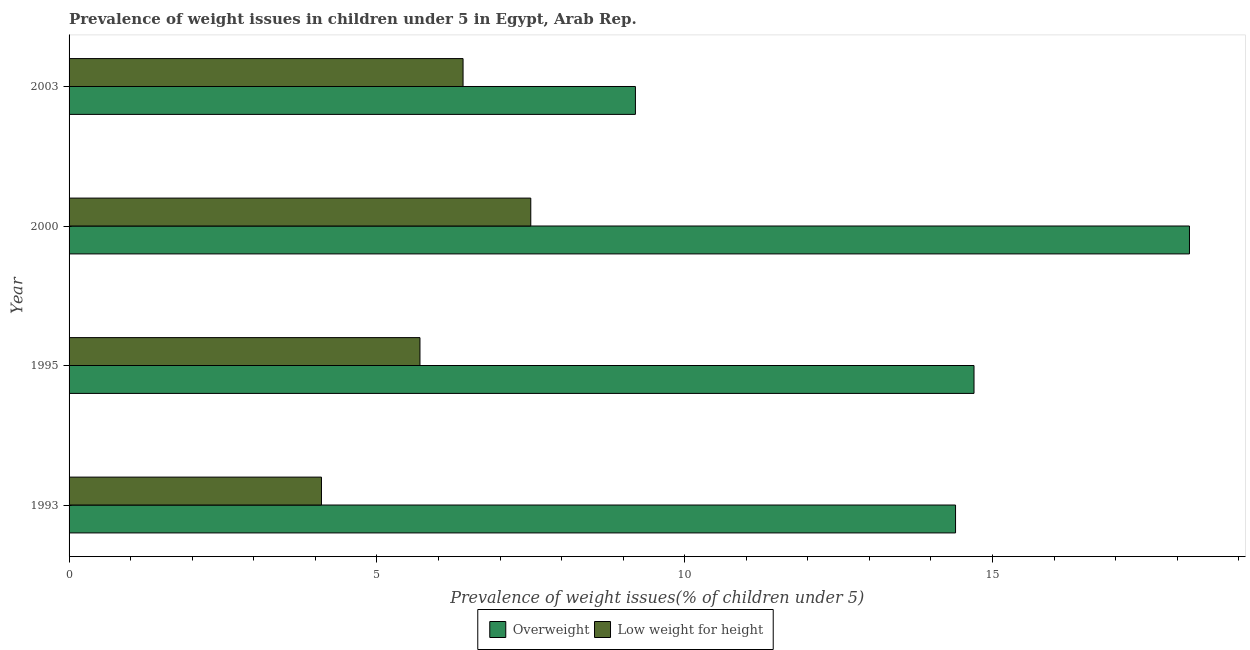How many different coloured bars are there?
Provide a short and direct response. 2. Are the number of bars per tick equal to the number of legend labels?
Ensure brevity in your answer.  Yes. How many bars are there on the 3rd tick from the top?
Your answer should be compact. 2. What is the label of the 4th group of bars from the top?
Give a very brief answer. 1993. What is the percentage of underweight children in 2000?
Your answer should be compact. 7.5. Across all years, what is the maximum percentage of underweight children?
Give a very brief answer. 7.5. Across all years, what is the minimum percentage of overweight children?
Give a very brief answer. 9.2. In which year was the percentage of underweight children maximum?
Ensure brevity in your answer.  2000. In which year was the percentage of underweight children minimum?
Your response must be concise. 1993. What is the total percentage of overweight children in the graph?
Provide a succinct answer. 56.5. What is the difference between the percentage of overweight children in 1993 and that in 2000?
Keep it short and to the point. -3.8. What is the difference between the percentage of overweight children in 1995 and the percentage of underweight children in 2003?
Ensure brevity in your answer.  8.3. What is the average percentage of underweight children per year?
Offer a very short reply. 5.92. In how many years, is the percentage of overweight children greater than 12 %?
Give a very brief answer. 3. Is the percentage of overweight children in 2000 less than that in 2003?
Offer a very short reply. No. Is the difference between the percentage of overweight children in 1995 and 2003 greater than the difference between the percentage of underweight children in 1995 and 2003?
Offer a terse response. Yes. What does the 1st bar from the top in 1995 represents?
Provide a succinct answer. Low weight for height. What does the 1st bar from the bottom in 1993 represents?
Provide a succinct answer. Overweight. How many bars are there?
Your answer should be very brief. 8. Are all the bars in the graph horizontal?
Keep it short and to the point. Yes. How many years are there in the graph?
Offer a very short reply. 4. What is the difference between two consecutive major ticks on the X-axis?
Ensure brevity in your answer.  5. Does the graph contain grids?
Keep it short and to the point. No. How many legend labels are there?
Your response must be concise. 2. What is the title of the graph?
Your response must be concise. Prevalence of weight issues in children under 5 in Egypt, Arab Rep. What is the label or title of the X-axis?
Provide a succinct answer. Prevalence of weight issues(% of children under 5). What is the label or title of the Y-axis?
Your answer should be compact. Year. What is the Prevalence of weight issues(% of children under 5) in Overweight in 1993?
Your answer should be very brief. 14.4. What is the Prevalence of weight issues(% of children under 5) in Low weight for height in 1993?
Keep it short and to the point. 4.1. What is the Prevalence of weight issues(% of children under 5) in Overweight in 1995?
Make the answer very short. 14.7. What is the Prevalence of weight issues(% of children under 5) in Low weight for height in 1995?
Your answer should be compact. 5.7. What is the Prevalence of weight issues(% of children under 5) of Overweight in 2000?
Your response must be concise. 18.2. What is the Prevalence of weight issues(% of children under 5) of Low weight for height in 2000?
Give a very brief answer. 7.5. What is the Prevalence of weight issues(% of children under 5) of Overweight in 2003?
Make the answer very short. 9.2. What is the Prevalence of weight issues(% of children under 5) of Low weight for height in 2003?
Your answer should be very brief. 6.4. Across all years, what is the maximum Prevalence of weight issues(% of children under 5) of Overweight?
Offer a terse response. 18.2. Across all years, what is the maximum Prevalence of weight issues(% of children under 5) in Low weight for height?
Your answer should be very brief. 7.5. Across all years, what is the minimum Prevalence of weight issues(% of children under 5) of Overweight?
Make the answer very short. 9.2. Across all years, what is the minimum Prevalence of weight issues(% of children under 5) of Low weight for height?
Keep it short and to the point. 4.1. What is the total Prevalence of weight issues(% of children under 5) in Overweight in the graph?
Provide a short and direct response. 56.5. What is the total Prevalence of weight issues(% of children under 5) in Low weight for height in the graph?
Ensure brevity in your answer.  23.7. What is the difference between the Prevalence of weight issues(% of children under 5) in Overweight in 1993 and that in 1995?
Give a very brief answer. -0.3. What is the difference between the Prevalence of weight issues(% of children under 5) of Low weight for height in 1993 and that in 1995?
Your response must be concise. -1.6. What is the difference between the Prevalence of weight issues(% of children under 5) in Overweight in 1993 and that in 2003?
Provide a short and direct response. 5.2. What is the difference between the Prevalence of weight issues(% of children under 5) in Low weight for height in 1993 and that in 2003?
Give a very brief answer. -2.3. What is the difference between the Prevalence of weight issues(% of children under 5) in Overweight in 1995 and that in 2003?
Your answer should be compact. 5.5. What is the difference between the Prevalence of weight issues(% of children under 5) in Low weight for height in 1995 and that in 2003?
Your answer should be compact. -0.7. What is the difference between the Prevalence of weight issues(% of children under 5) in Overweight in 2000 and that in 2003?
Keep it short and to the point. 9. What is the difference between the Prevalence of weight issues(% of children under 5) in Overweight in 1993 and the Prevalence of weight issues(% of children under 5) in Low weight for height in 1995?
Your answer should be compact. 8.7. What is the difference between the Prevalence of weight issues(% of children under 5) in Overweight in 1993 and the Prevalence of weight issues(% of children under 5) in Low weight for height in 2003?
Make the answer very short. 8. What is the difference between the Prevalence of weight issues(% of children under 5) in Overweight in 1995 and the Prevalence of weight issues(% of children under 5) in Low weight for height in 2000?
Offer a very short reply. 7.2. What is the difference between the Prevalence of weight issues(% of children under 5) of Overweight in 1995 and the Prevalence of weight issues(% of children under 5) of Low weight for height in 2003?
Offer a very short reply. 8.3. What is the difference between the Prevalence of weight issues(% of children under 5) in Overweight in 2000 and the Prevalence of weight issues(% of children under 5) in Low weight for height in 2003?
Provide a short and direct response. 11.8. What is the average Prevalence of weight issues(% of children under 5) in Overweight per year?
Your response must be concise. 14.12. What is the average Prevalence of weight issues(% of children under 5) in Low weight for height per year?
Offer a terse response. 5.92. In the year 1995, what is the difference between the Prevalence of weight issues(% of children under 5) in Overweight and Prevalence of weight issues(% of children under 5) in Low weight for height?
Your answer should be very brief. 9. In the year 2000, what is the difference between the Prevalence of weight issues(% of children under 5) of Overweight and Prevalence of weight issues(% of children under 5) of Low weight for height?
Provide a succinct answer. 10.7. In the year 2003, what is the difference between the Prevalence of weight issues(% of children under 5) in Overweight and Prevalence of weight issues(% of children under 5) in Low weight for height?
Give a very brief answer. 2.8. What is the ratio of the Prevalence of weight issues(% of children under 5) in Overweight in 1993 to that in 1995?
Your response must be concise. 0.98. What is the ratio of the Prevalence of weight issues(% of children under 5) in Low weight for height in 1993 to that in 1995?
Ensure brevity in your answer.  0.72. What is the ratio of the Prevalence of weight issues(% of children under 5) of Overweight in 1993 to that in 2000?
Offer a very short reply. 0.79. What is the ratio of the Prevalence of weight issues(% of children under 5) in Low weight for height in 1993 to that in 2000?
Keep it short and to the point. 0.55. What is the ratio of the Prevalence of weight issues(% of children under 5) of Overweight in 1993 to that in 2003?
Make the answer very short. 1.57. What is the ratio of the Prevalence of weight issues(% of children under 5) of Low weight for height in 1993 to that in 2003?
Offer a very short reply. 0.64. What is the ratio of the Prevalence of weight issues(% of children under 5) of Overweight in 1995 to that in 2000?
Your response must be concise. 0.81. What is the ratio of the Prevalence of weight issues(% of children under 5) in Low weight for height in 1995 to that in 2000?
Offer a terse response. 0.76. What is the ratio of the Prevalence of weight issues(% of children under 5) of Overweight in 1995 to that in 2003?
Your answer should be very brief. 1.6. What is the ratio of the Prevalence of weight issues(% of children under 5) in Low weight for height in 1995 to that in 2003?
Offer a terse response. 0.89. What is the ratio of the Prevalence of weight issues(% of children under 5) in Overweight in 2000 to that in 2003?
Your answer should be compact. 1.98. What is the ratio of the Prevalence of weight issues(% of children under 5) of Low weight for height in 2000 to that in 2003?
Give a very brief answer. 1.17. What is the difference between the highest and the second highest Prevalence of weight issues(% of children under 5) of Overweight?
Your response must be concise. 3.5. What is the difference between the highest and the second highest Prevalence of weight issues(% of children under 5) in Low weight for height?
Provide a short and direct response. 1.1. What is the difference between the highest and the lowest Prevalence of weight issues(% of children under 5) of Overweight?
Your response must be concise. 9. 